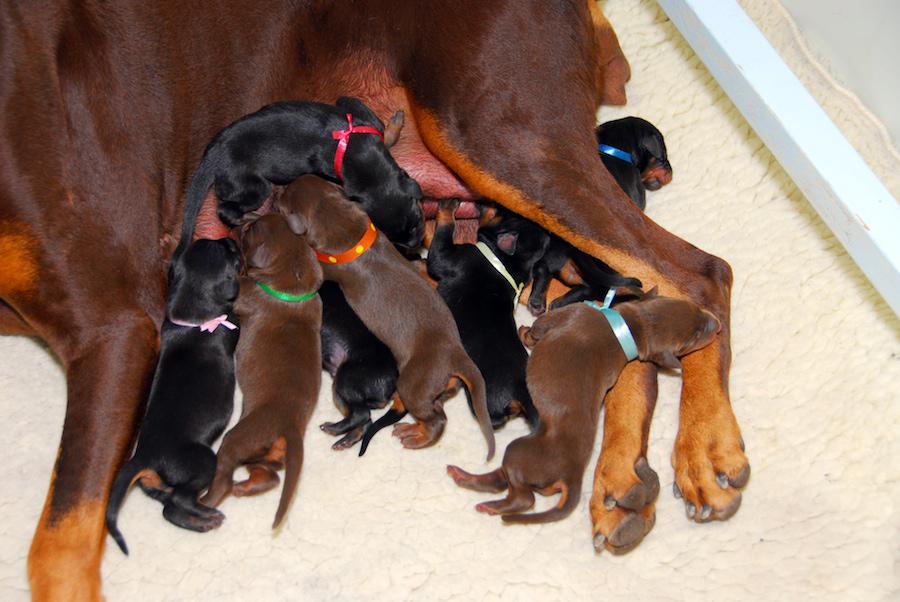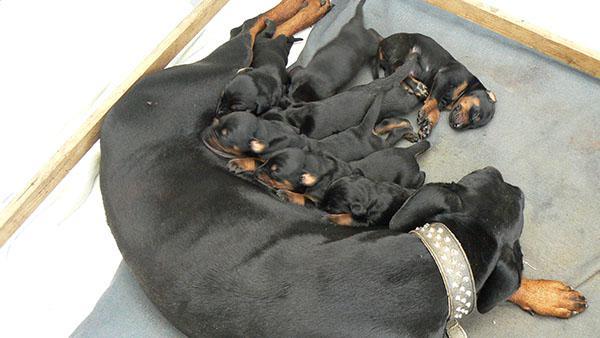The first image is the image on the left, the second image is the image on the right. For the images displayed, is the sentence "Multiple puppies are standing around at least part of a round silver bowl shape in at least one image." factually correct? Answer yes or no. No. The first image is the image on the left, the second image is the image on the right. Analyze the images presented: Is the assertion "Dogs are eating out of a bowl." valid? Answer yes or no. No. 